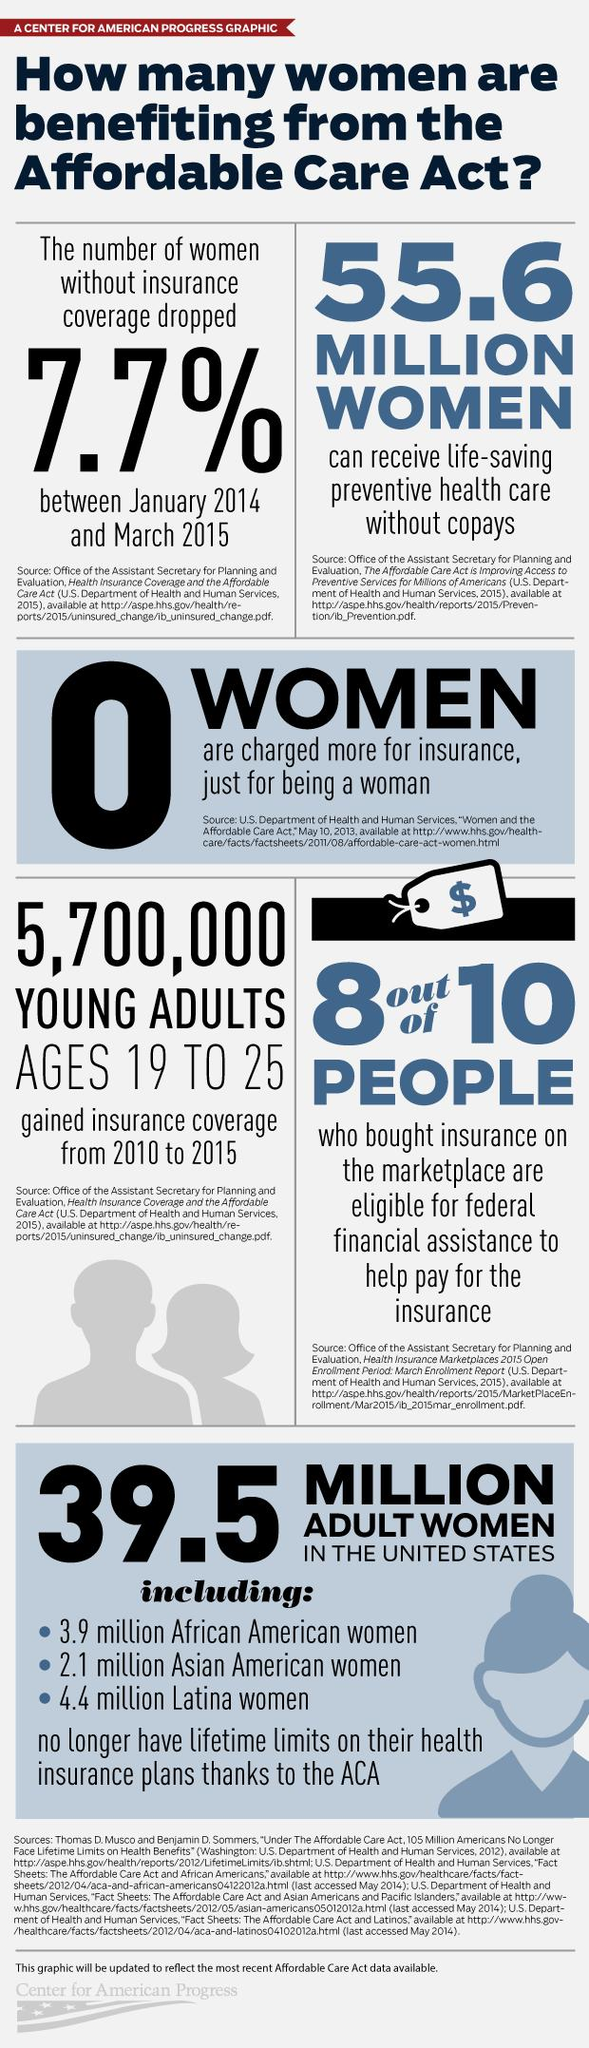Highlight a few significant elements in this photo. The total number of adult women belonging to the ethnic race groups of African, Asian, and Latina is 10.4 million. 